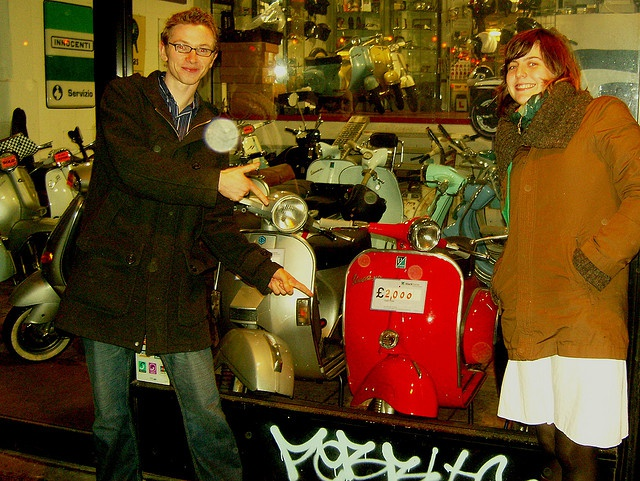Describe the objects in this image and their specific colors. I can see people in olive, black, darkgreen, and tan tones, people in olive, brown, lightgray, and maroon tones, motorcycle in olive, red, brown, maroon, and black tones, motorcycle in olive, black, tan, and khaki tones, and motorcycle in olive, black, and maroon tones in this image. 